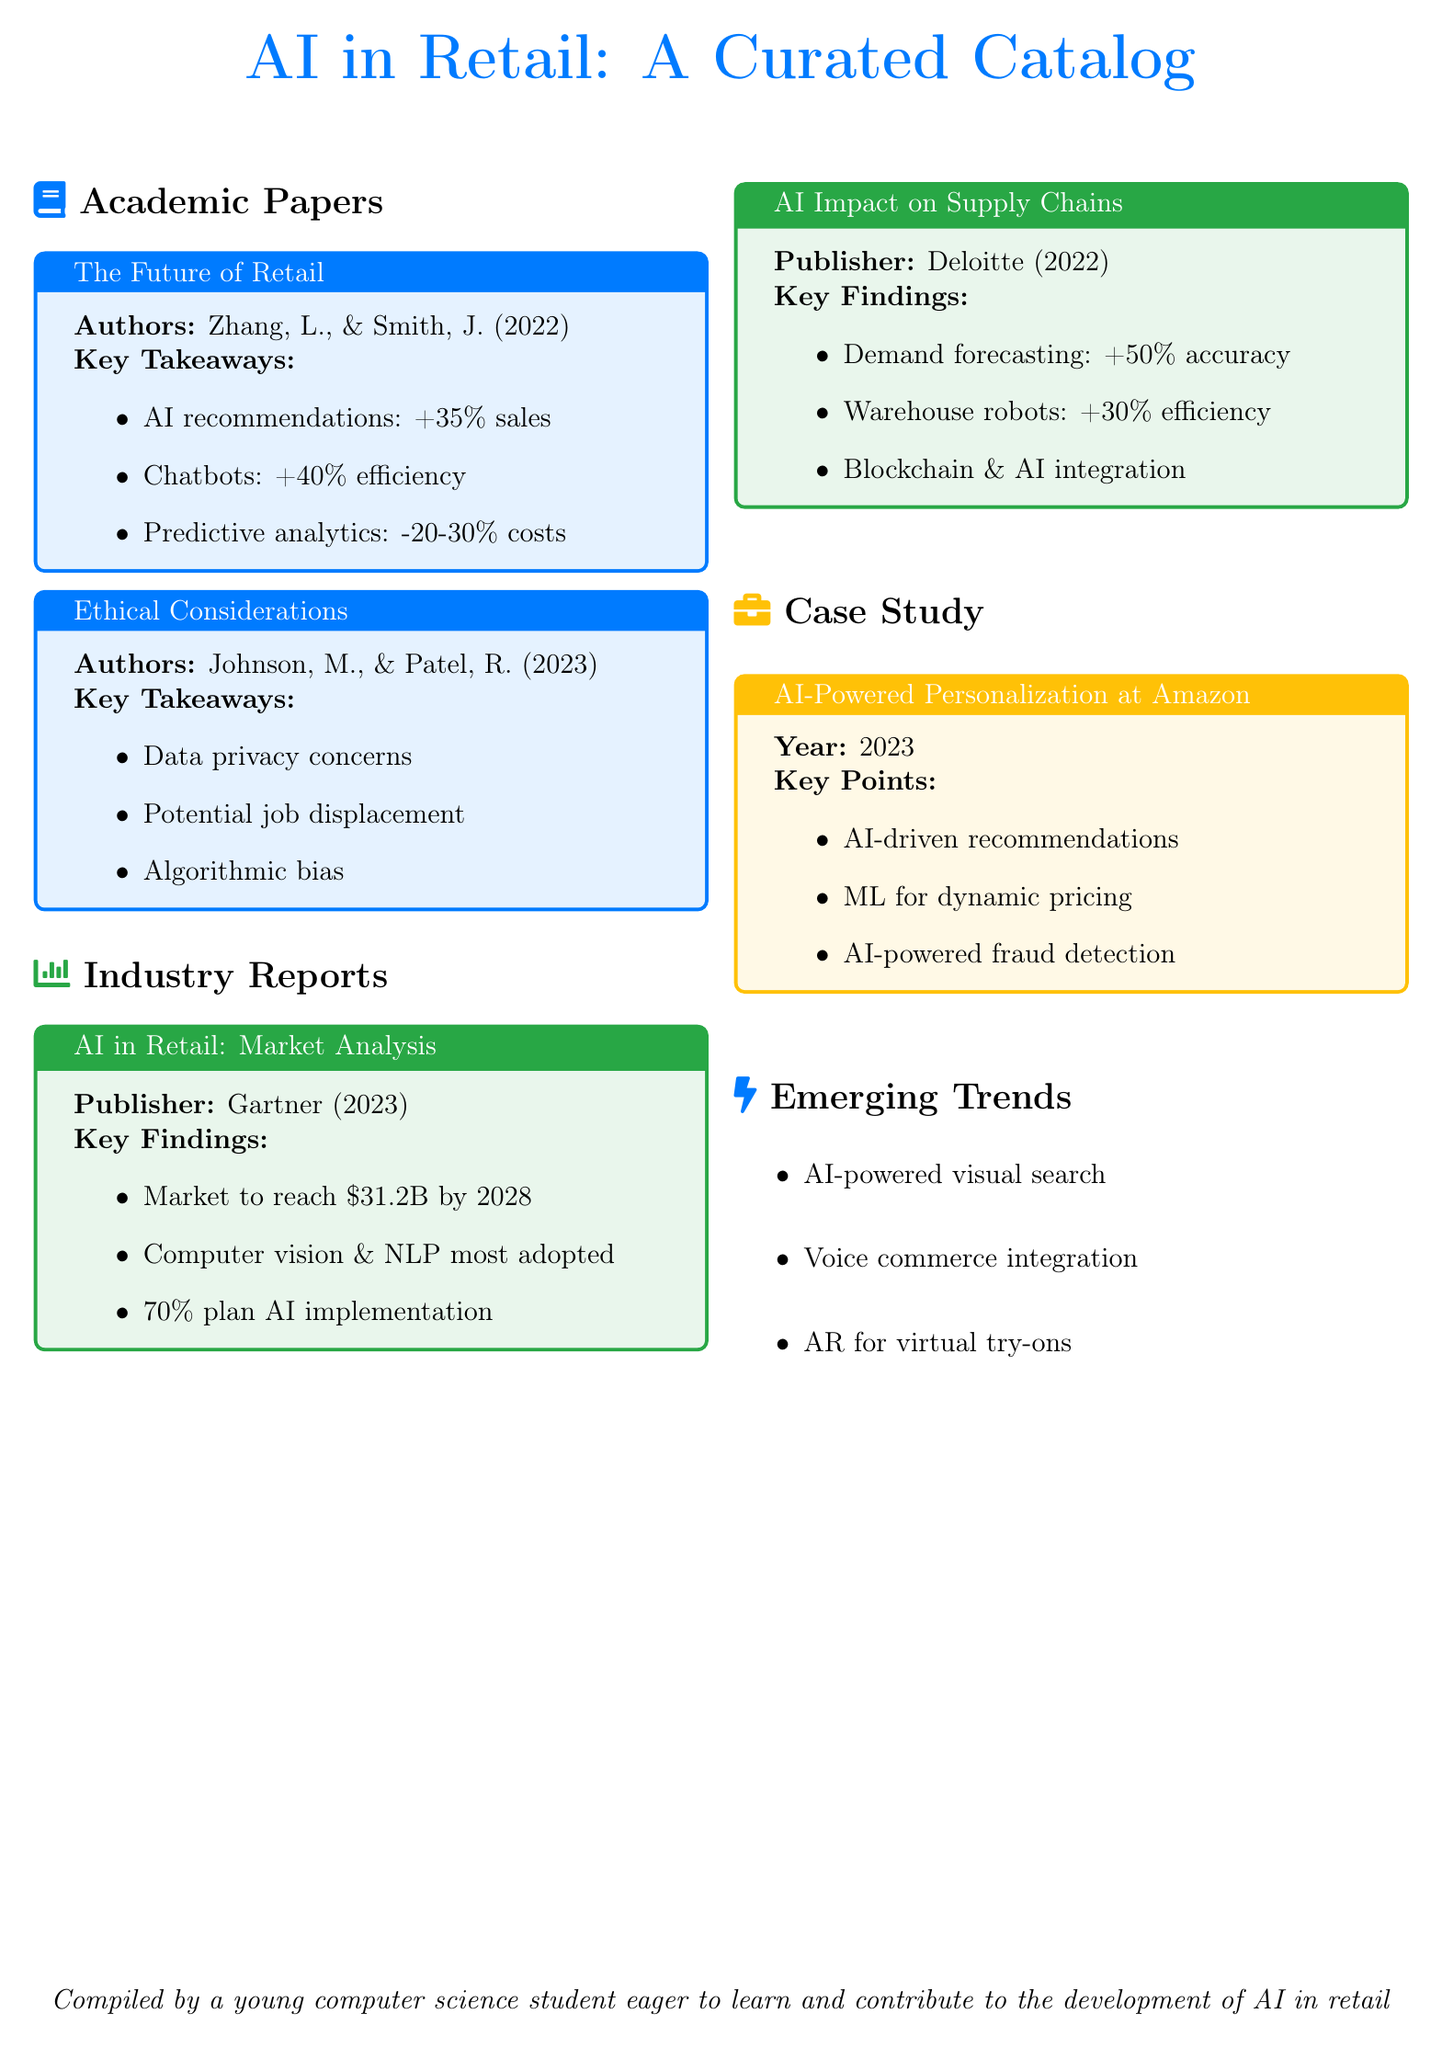What is the title of the first academic paper? The title of the first academic paper listed is "The Future of Retail."
Answer: The Future of Retail How much is the AI in retail market projected to reach by 2028? The market is projected to reach $31.2B by 2028.
Answer: $31.2B What percentage increase in sales does AI recommendations provide? AI recommendations lead to a 35% increase in sales.
Answer: +35% Which technologies are noted as the most adopted in retail AI? The most adopted technologies noted are computer vision and NLP.
Answer: Computer vision & NLP What is one potential issue highlighted in the section on ethical considerations? One potential issue highlighted is algorithmic bias.
Answer: Algorithmic bias How much more accurate is demand forecasting with AI, according to Deloitte? Demand forecasting with AI results in 50% more accuracy.
Answer: +50% accuracy What key point is outlined for Amazon's AI-powered personalization? A key point outlined is AI-driven recommendations.
Answer: AI-driven recommendations What type of technology is mentioned for virtual try-ons? The technology mentioned for virtual try-ons is AR.
Answer: AR What year was the case study about Amazon published? The case study about Amazon was published in 2023.
Answer: 2023 